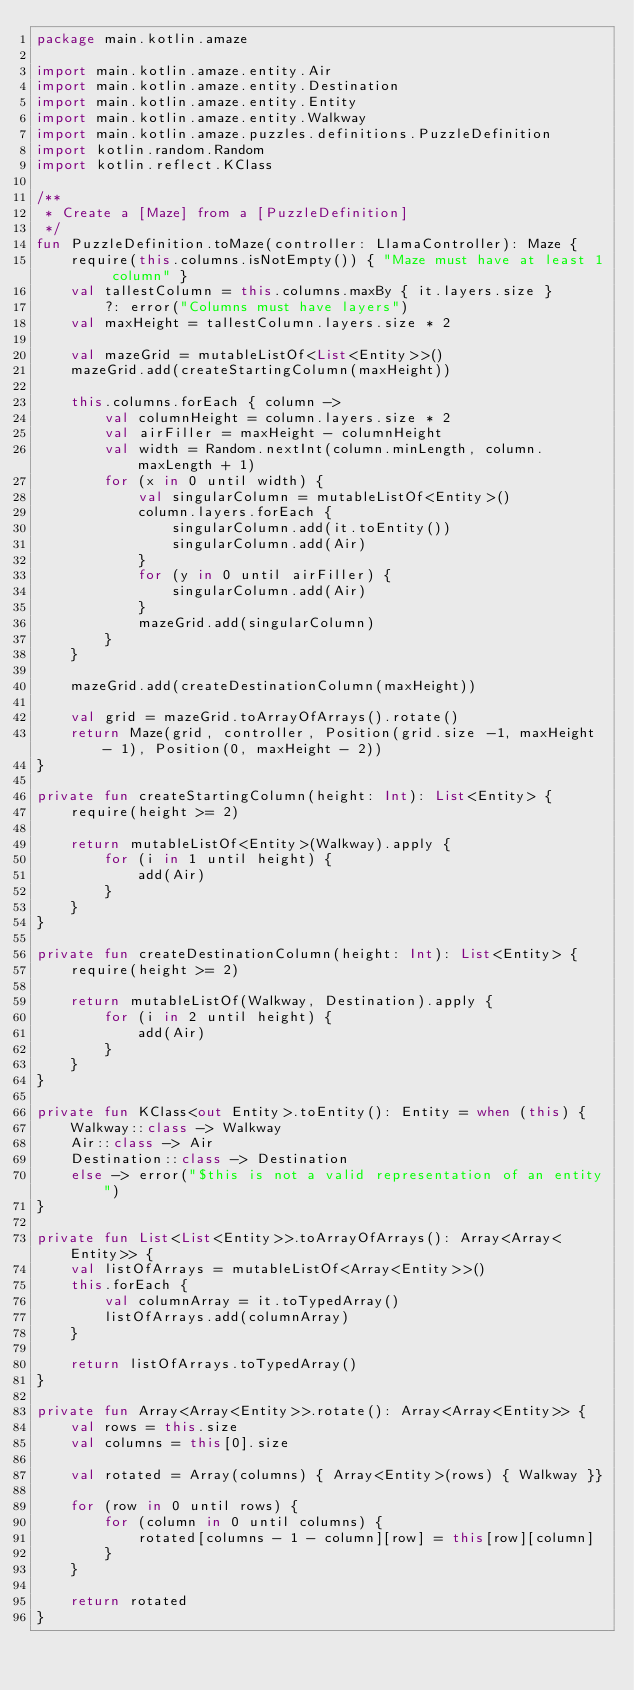Convert code to text. <code><loc_0><loc_0><loc_500><loc_500><_Kotlin_>package main.kotlin.amaze

import main.kotlin.amaze.entity.Air
import main.kotlin.amaze.entity.Destination
import main.kotlin.amaze.entity.Entity
import main.kotlin.amaze.entity.Walkway
import main.kotlin.amaze.puzzles.definitions.PuzzleDefinition
import kotlin.random.Random
import kotlin.reflect.KClass

/**
 * Create a [Maze] from a [PuzzleDefinition]
 */
fun PuzzleDefinition.toMaze(controller: LlamaController): Maze {
    require(this.columns.isNotEmpty()) { "Maze must have at least 1 column" }
    val tallestColumn = this.columns.maxBy { it.layers.size }
        ?: error("Columns must have layers")
    val maxHeight = tallestColumn.layers.size * 2

    val mazeGrid = mutableListOf<List<Entity>>()
    mazeGrid.add(createStartingColumn(maxHeight))

    this.columns.forEach { column ->
        val columnHeight = column.layers.size * 2
        val airFiller = maxHeight - columnHeight
        val width = Random.nextInt(column.minLength, column.maxLength + 1)
        for (x in 0 until width) {
            val singularColumn = mutableListOf<Entity>()
            column.layers.forEach {
                singularColumn.add(it.toEntity())
                singularColumn.add(Air)
            }
            for (y in 0 until airFiller) {
                singularColumn.add(Air)
            }
            mazeGrid.add(singularColumn)
        }
    }

    mazeGrid.add(createDestinationColumn(maxHeight))

    val grid = mazeGrid.toArrayOfArrays().rotate()
    return Maze(grid, controller, Position(grid.size -1, maxHeight - 1), Position(0, maxHeight - 2))
}

private fun createStartingColumn(height: Int): List<Entity> {
    require(height >= 2)

    return mutableListOf<Entity>(Walkway).apply {
        for (i in 1 until height) {
            add(Air)
        }
    }
}

private fun createDestinationColumn(height: Int): List<Entity> {
    require(height >= 2)

    return mutableListOf(Walkway, Destination).apply {
        for (i in 2 until height) {
            add(Air)
        }
    }
}

private fun KClass<out Entity>.toEntity(): Entity = when (this) {
    Walkway::class -> Walkway
    Air::class -> Air
    Destination::class -> Destination
    else -> error("$this is not a valid representation of an entity")
}

private fun List<List<Entity>>.toArrayOfArrays(): Array<Array<Entity>> {
    val listOfArrays = mutableListOf<Array<Entity>>()
    this.forEach {
        val columnArray = it.toTypedArray()
        listOfArrays.add(columnArray)
    }

    return listOfArrays.toTypedArray()
}

private fun Array<Array<Entity>>.rotate(): Array<Array<Entity>> {
    val rows = this.size
    val columns = this[0].size

    val rotated = Array(columns) { Array<Entity>(rows) { Walkway }}

    for (row in 0 until rows) {
        for (column in 0 until columns) {
            rotated[columns - 1 - column][row] = this[row][column]
        }
    }

    return rotated
}
</code> 